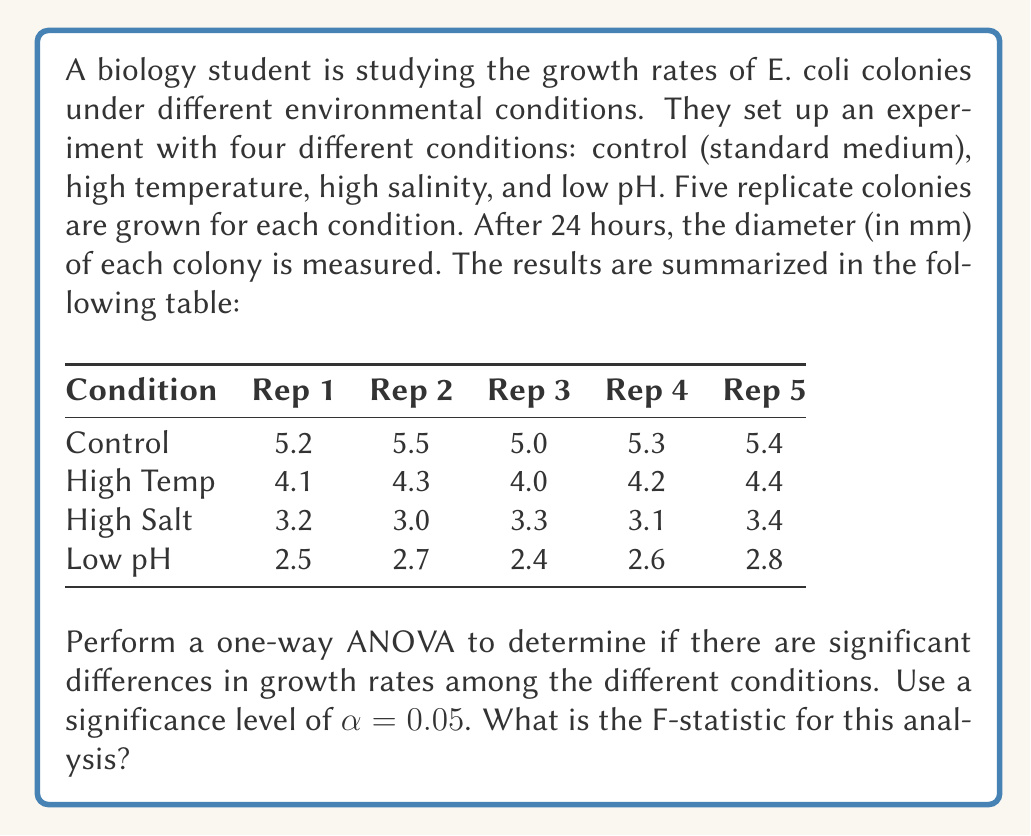Solve this math problem. To perform a one-way ANOVA, we need to follow these steps:

1) Calculate the total sum of squares (SST), between-group sum of squares (SSB), and within-group sum of squares (SSW).

2) Calculate the degrees of freedom for between groups (dfB) and within groups (dfW).

3) Calculate the mean square between groups (MSB) and mean square within groups (MSW).

4) Calculate the F-statistic.

Step 1: Calculating sums of squares

First, let's calculate the grand mean:
$\bar{X} = \frac{5.2 + 5.5 + ... + 2.8}{20} = 3.87$

Now, we can calculate SST:
$$SST = \sum_{i=1}^{4}\sum_{j=1}^{5}(X_{ij} - \bar{X})^2 = 36.298$$

For SSB, we need the group means:
$\bar{X}_1 = 5.28$ (Control)
$\bar{X}_2 = 4.20$ (High Temp)
$\bar{X}_3 = 3.20$ (High Salt)
$\bar{X}_4 = 2.60$ (Low pH)

$$SSB = 5\sum_{i=1}^{4}(\bar{X}_i - \bar{X})^2 = 35.778$$

SSW can be calculated as:
$$SSW = SST - SSB = 36.298 - 35.778 = 0.52$$

Step 2: Degrees of freedom

dfB = number of groups - 1 = 4 - 1 = 3
dfW = total number of observations - number of groups = 20 - 4 = 16

Step 3: Mean squares

$$MSB = \frac{SSB}{dfB} = \frac{35.778}{3} = 11.926$$
$$MSW = \frac{SSW}{dfW} = \frac{0.52}{16} = 0.0325$$

Step 4: F-statistic

$$F = \frac{MSB}{MSW} = \frac{11.926}{0.0325} = 366.95$$

Therefore, the F-statistic for this analysis is 366.95.
Answer: $F = 366.95$ 